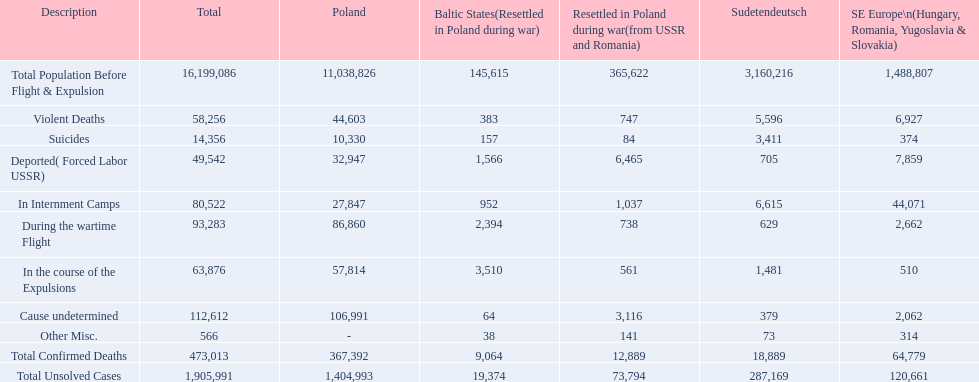What was the complete tally of validated mortalities? 473,013. Parse the full table in json format. {'header': ['Description', 'Total', 'Poland', 'Baltic States(Resettled in Poland during war)', 'Resettled in Poland during war(from USSR and Romania)', 'Sudetendeutsch', 'SE Europe\\n(Hungary, Romania, Yugoslavia & Slovakia)'], 'rows': [['Total Population Before Flight & Expulsion', '16,199,086', '11,038,826', '145,615', '365,622', '3,160,216', '1,488,807'], ['Violent Deaths', '58,256', '44,603', '383', '747', '5,596', '6,927'], ['Suicides', '14,356', '10,330', '157', '84', '3,411', '374'], ['Deported( Forced Labor USSR)', '49,542', '32,947', '1,566', '6,465', '705', '7,859'], ['In Internment Camps', '80,522', '27,847', '952', '1,037', '6,615', '44,071'], ['During the wartime Flight', '93,283', '86,860', '2,394', '738', '629', '2,662'], ['In the course of the Expulsions', '63,876', '57,814', '3,510', '561', '1,481', '510'], ['Cause undetermined', '112,612', '106,991', '64', '3,116', '379', '2,062'], ['Other Misc.', '566', '-', '38', '141', '73', '314'], ['Total Confirmed Deaths', '473,013', '367,392', '9,064', '12,889', '18,889', '64,779'], ['Total Unsolved Cases', '1,905,991', '1,404,993', '19,374', '73,794', '287,169', '120,661']]} Of these, how many were forceful? 58,256. 